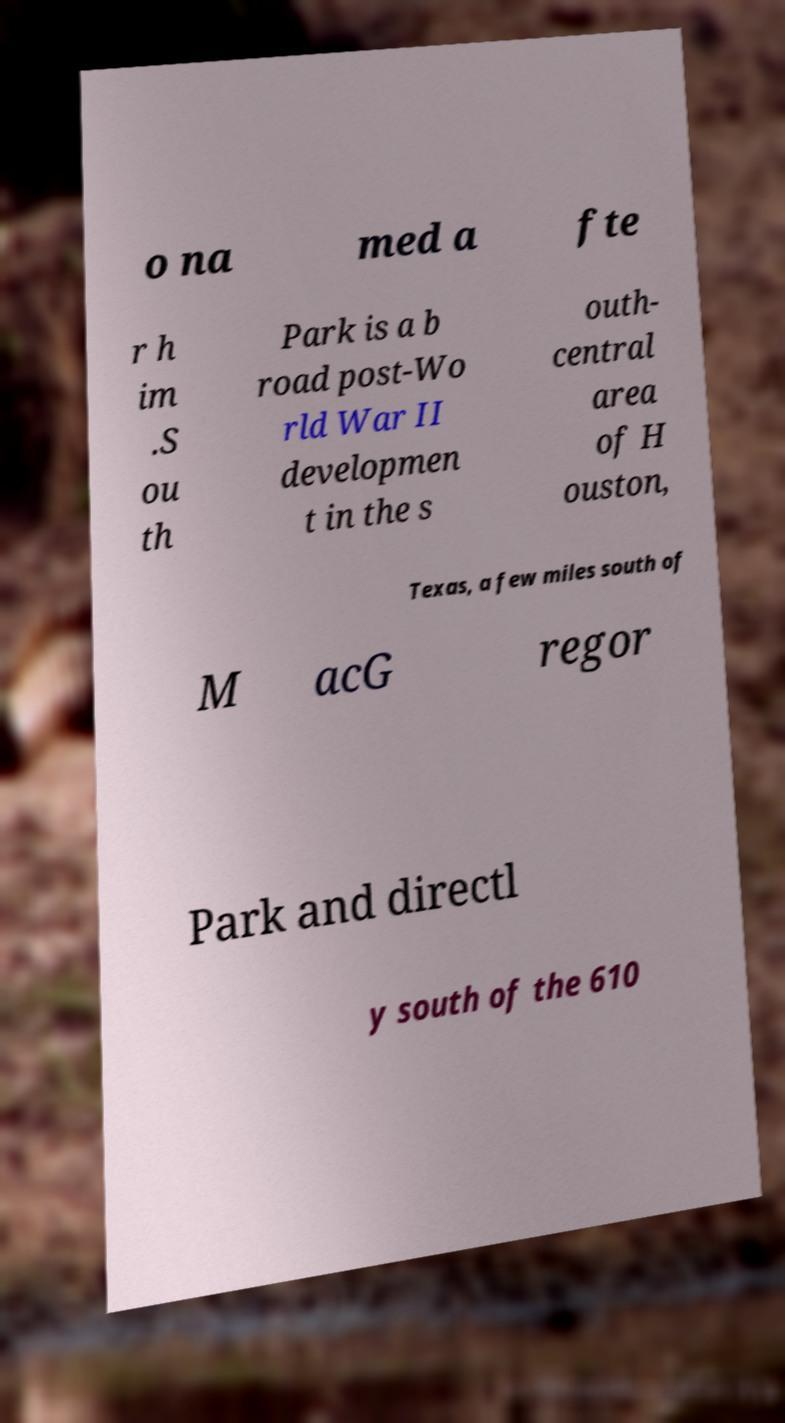Could you extract and type out the text from this image? o na med a fte r h im .S ou th Park is a b road post-Wo rld War II developmen t in the s outh- central area of H ouston, Texas, a few miles south of M acG regor Park and directl y south of the 610 